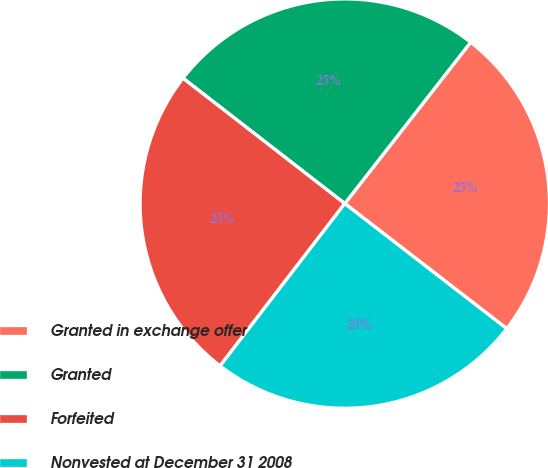Convert chart to OTSL. <chart><loc_0><loc_0><loc_500><loc_500><pie_chart><fcel>Granted in exchange offer<fcel>Granted<fcel>Forfeited<fcel>Nonvested at December 31 2008<nl><fcel>24.92%<fcel>25.05%<fcel>25.07%<fcel>24.96%<nl></chart> 